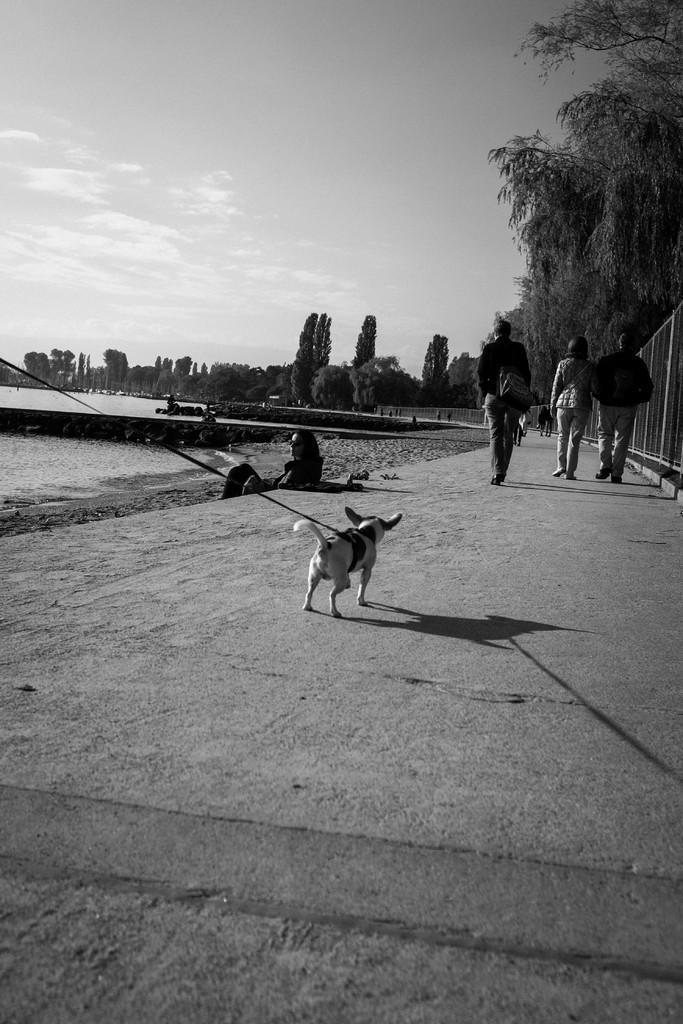How would you summarize this image in a sentence or two? In the center of the image we can see a few people are walking and wearing bags. And we can see one person sitting, one dog, in which we can see one belt tied to it and a fence. In the background we can see the sky, clouds, trees, water etc. 